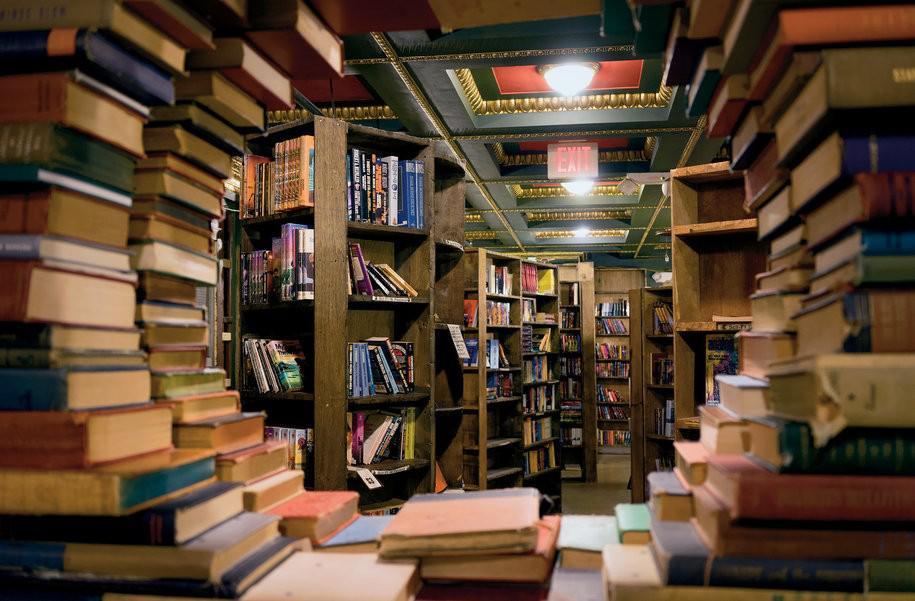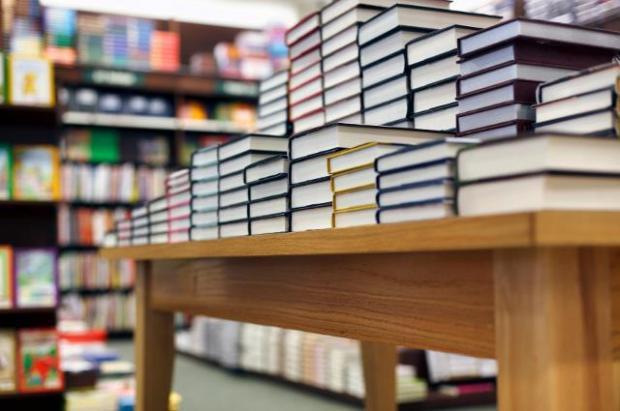The first image is the image on the left, the second image is the image on the right. Given the left and right images, does the statement "Several of the books on the shelves have yellow stickers." hold true? Answer yes or no. No. The first image is the image on the left, the second image is the image on the right. Assess this claim about the two images: "In at least one image, books are stacked on their sides on shelves, some with yellow rectangles on their spines.". Correct or not? Answer yes or no. No. 